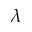<formula> <loc_0><loc_0><loc_500><loc_500>\lambda</formula> 